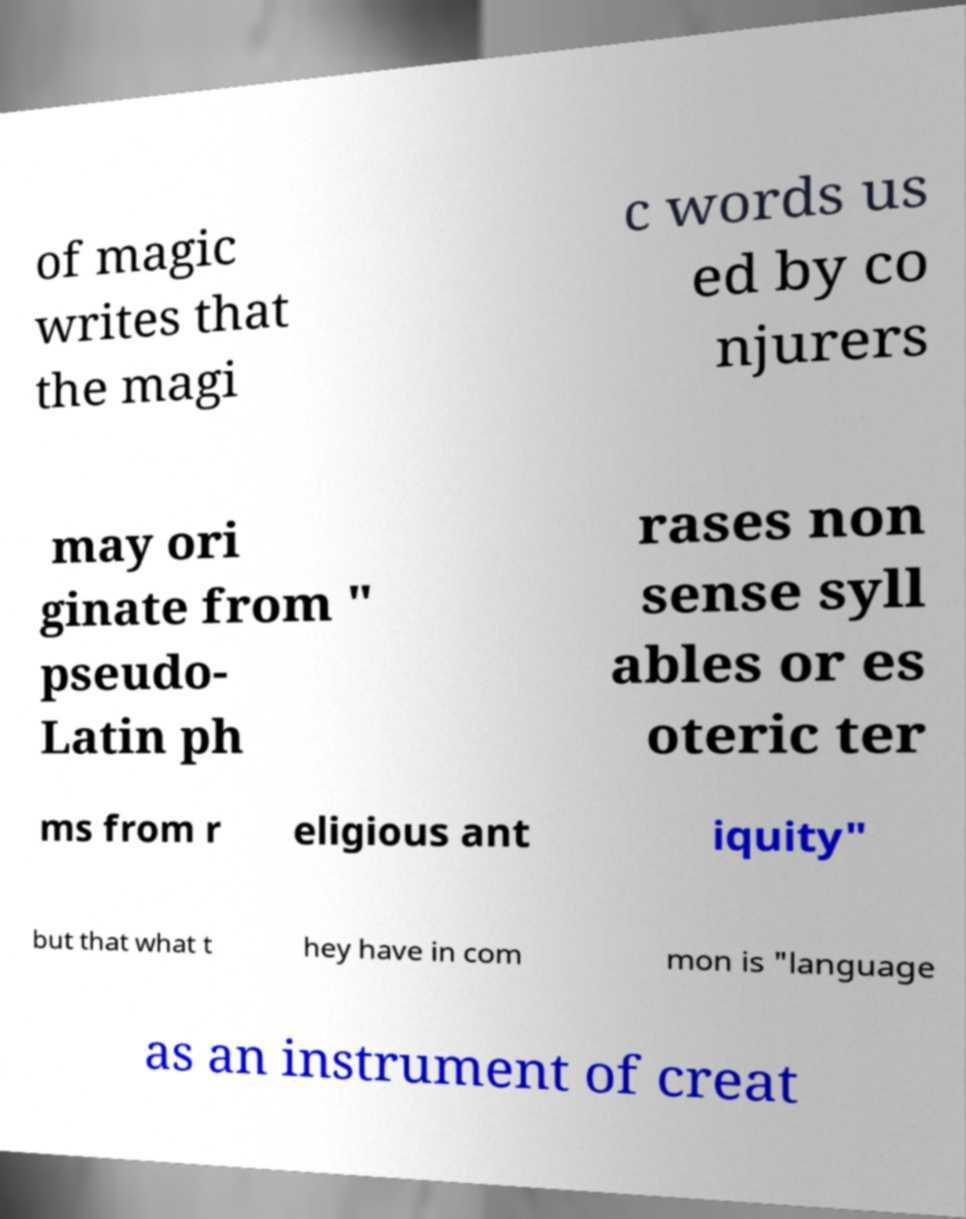Can you read and provide the text displayed in the image?This photo seems to have some interesting text. Can you extract and type it out for me? of magic writes that the magi c words us ed by co njurers may ori ginate from " pseudo- Latin ph rases non sense syll ables or es oteric ter ms from r eligious ant iquity" but that what t hey have in com mon is "language as an instrument of creat 